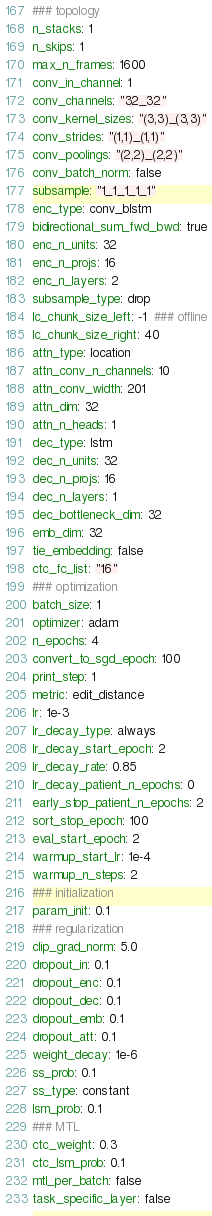Convert code to text. <code><loc_0><loc_0><loc_500><loc_500><_YAML_>### topology
n_stacks: 1
n_skips: 1
max_n_frames: 1600
conv_in_channel: 1
conv_channels: "32_32"
conv_kernel_sizes: "(3,3)_(3,3)"
conv_strides: "(1,1)_(1,1)"
conv_poolings: "(2,2)_(2,2)"
conv_batch_norm: false
subsample: "1_1_1_1_1"
enc_type: conv_blstm
bidirectional_sum_fwd_bwd: true
enc_n_units: 32
enc_n_projs: 16
enc_n_layers: 2
subsample_type: drop
lc_chunk_size_left: -1  ### offline
lc_chunk_size_right: 40
attn_type: location
attn_conv_n_channels: 10
attn_conv_width: 201
attn_dim: 32
attn_n_heads: 1
dec_type: lstm
dec_n_units: 32
dec_n_projs: 16
dec_n_layers: 1
dec_bottleneck_dim: 32
emb_dim: 32
tie_embedding: false
ctc_fc_list: "16"
### optimization
batch_size: 1
optimizer: adam
n_epochs: 4
convert_to_sgd_epoch: 100
print_step: 1
metric: edit_distance
lr: 1e-3
lr_decay_type: always
lr_decay_start_epoch: 2
lr_decay_rate: 0.85
lr_decay_patient_n_epochs: 0
early_stop_patient_n_epochs: 2
sort_stop_epoch: 100
eval_start_epoch: 2
warmup_start_lr: 1e-4
warmup_n_steps: 2
### initialization
param_init: 0.1
### regularization
clip_grad_norm: 5.0
dropout_in: 0.1
dropout_enc: 0.1
dropout_dec: 0.1
dropout_emb: 0.1
dropout_att: 0.1
weight_decay: 1e-6
ss_prob: 0.1
ss_type: constant
lsm_prob: 0.1
### MTL
ctc_weight: 0.3
ctc_lsm_prob: 0.1
mtl_per_batch: false
task_specific_layer: false
</code> 